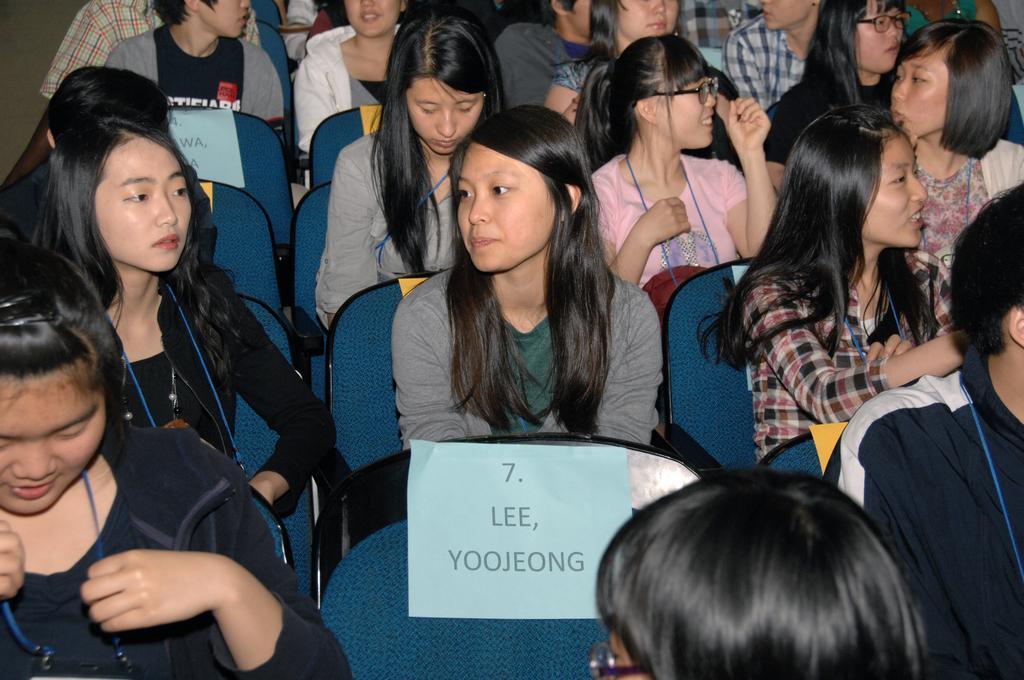How would you summarize this image in a sentence or two? In this picture, we see the people are sitting on the chairs. At the bottom of the picture, we see a paper in blue color with some text written on it. 